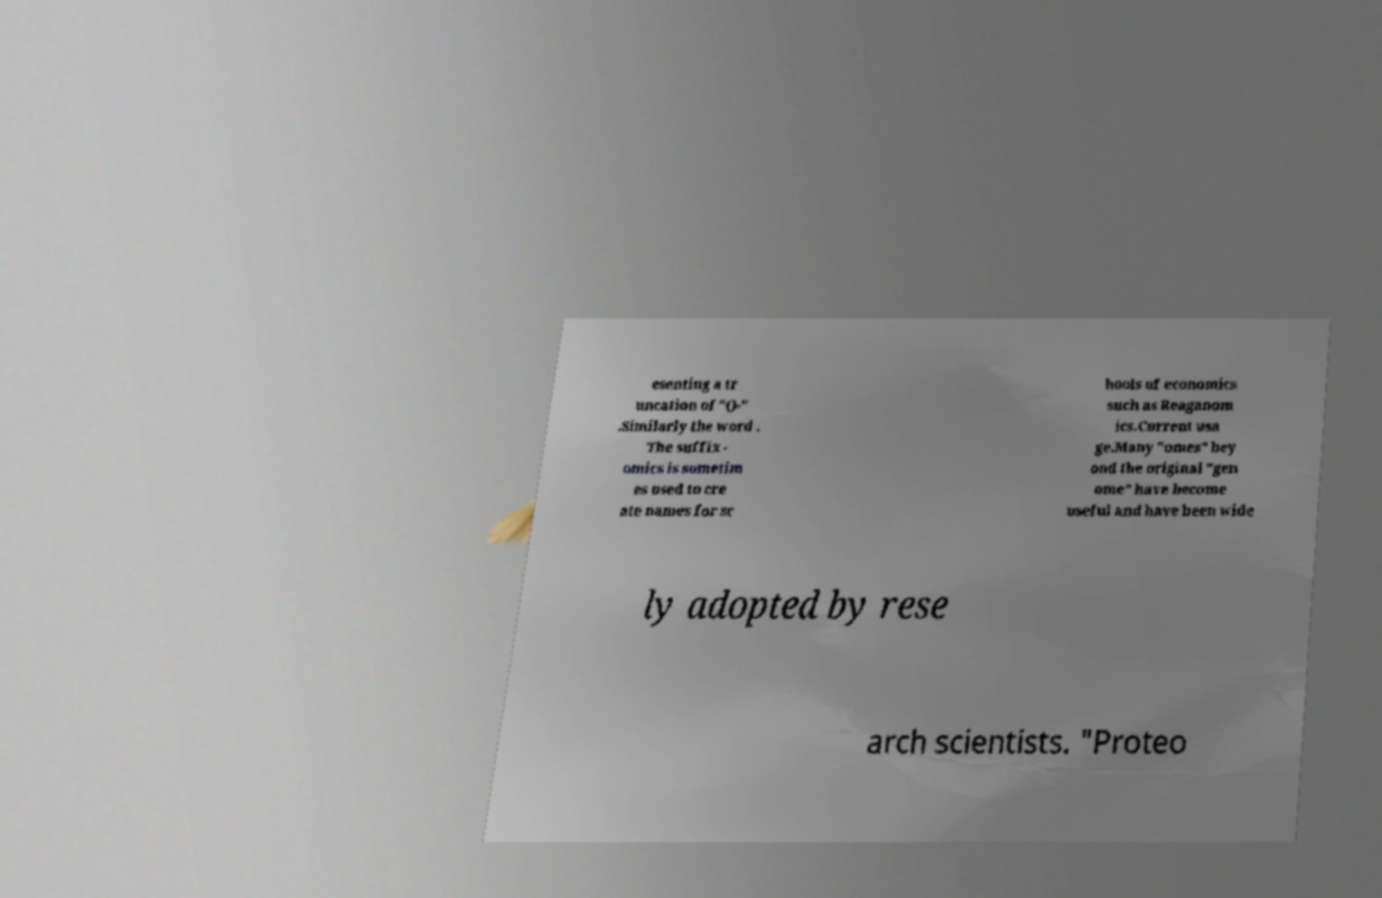What messages or text are displayed in this image? I need them in a readable, typed format. esenting a tr uncation of "()-" .Similarly the word . The suffix - omics is sometim es used to cre ate names for sc hools of economics such as Reaganom ics.Current usa ge.Many "omes" bey ond the original "gen ome" have become useful and have been wide ly adopted by rese arch scientists. "Proteo 